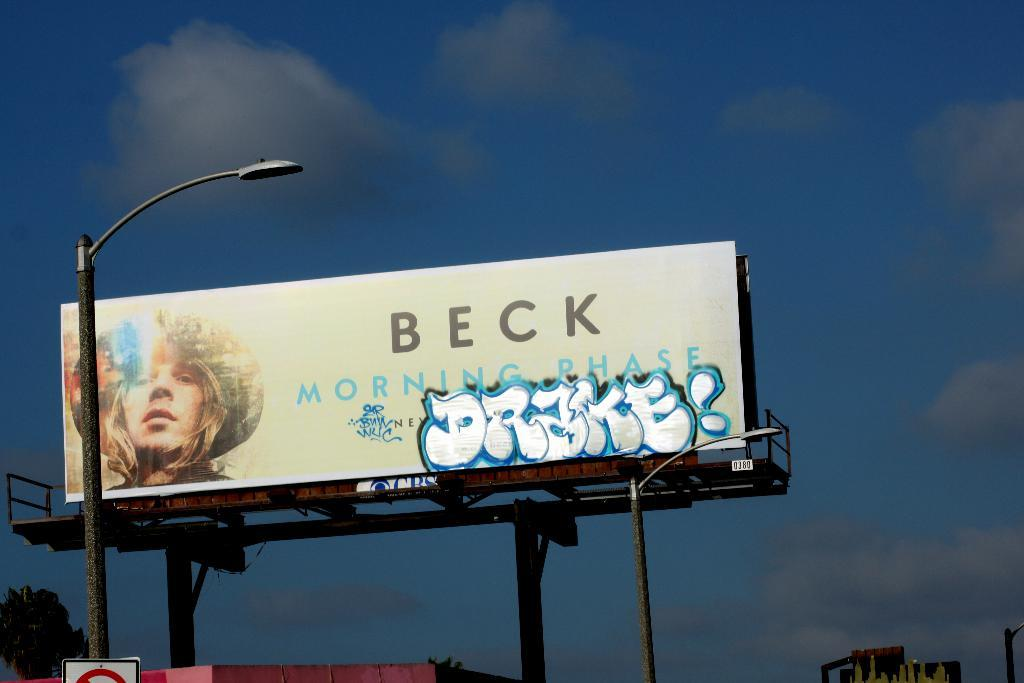Provide a one-sentence caption for the provided image. a large billboard with Beck on the top of it. 